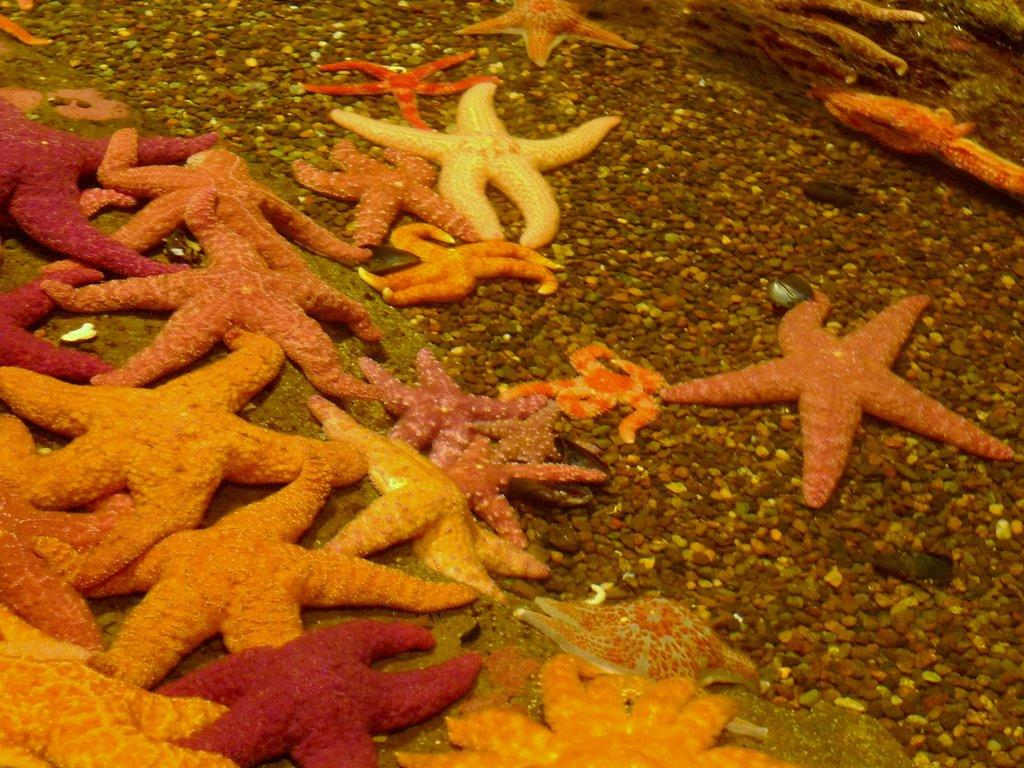What type of marine animals can be seen on the ground in the image? There are starfishes on the ground in the image. What else can be found on the ground in the image? There are many stones on the ground in the image. What type of hall can be seen in the image? There is no hall present in the image; it features starfishes and stones on the ground. What type of amusement can be found in the image? There is no amusement present in the image; it features starfishes and stones on the ground. 